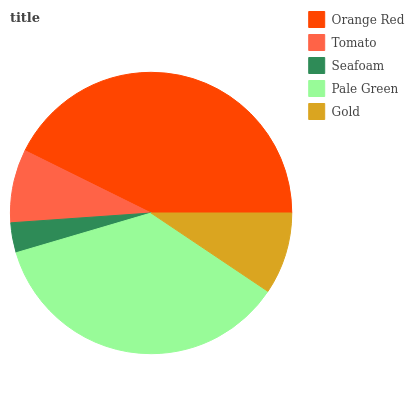Is Seafoam the minimum?
Answer yes or no. Yes. Is Orange Red the maximum?
Answer yes or no. Yes. Is Tomato the minimum?
Answer yes or no. No. Is Tomato the maximum?
Answer yes or no. No. Is Orange Red greater than Tomato?
Answer yes or no. Yes. Is Tomato less than Orange Red?
Answer yes or no. Yes. Is Tomato greater than Orange Red?
Answer yes or no. No. Is Orange Red less than Tomato?
Answer yes or no. No. Is Gold the high median?
Answer yes or no. Yes. Is Gold the low median?
Answer yes or no. Yes. Is Pale Green the high median?
Answer yes or no. No. Is Tomato the low median?
Answer yes or no. No. 